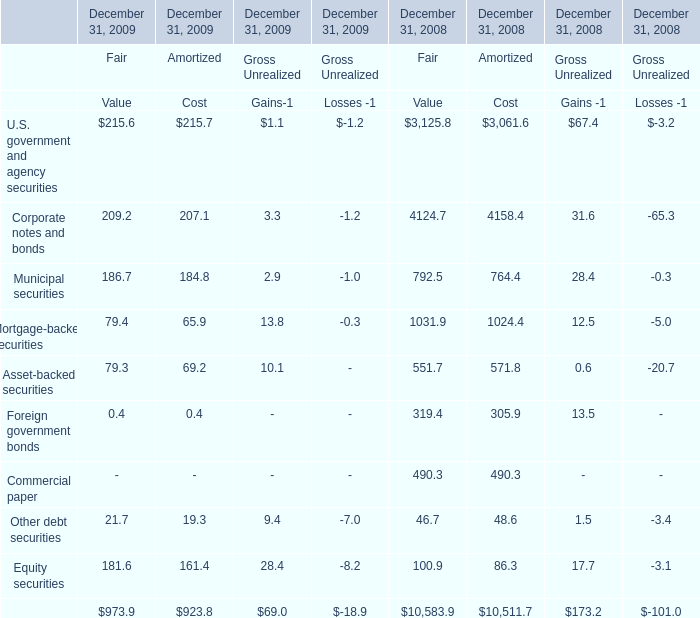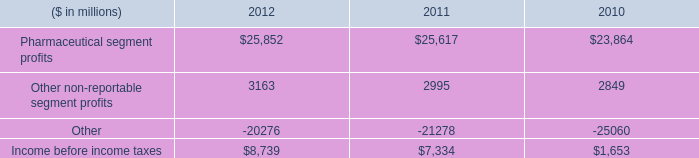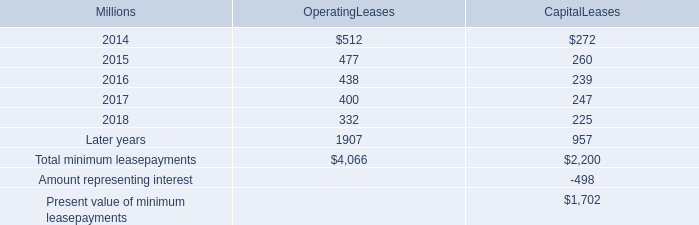What is the total amount of Income before income taxes of 2012, and Corporate notes and bonds of December 31, 2008 Amortized Cost ? 
Computations: (8739.0 + 4158.4)
Answer: 12897.4. 